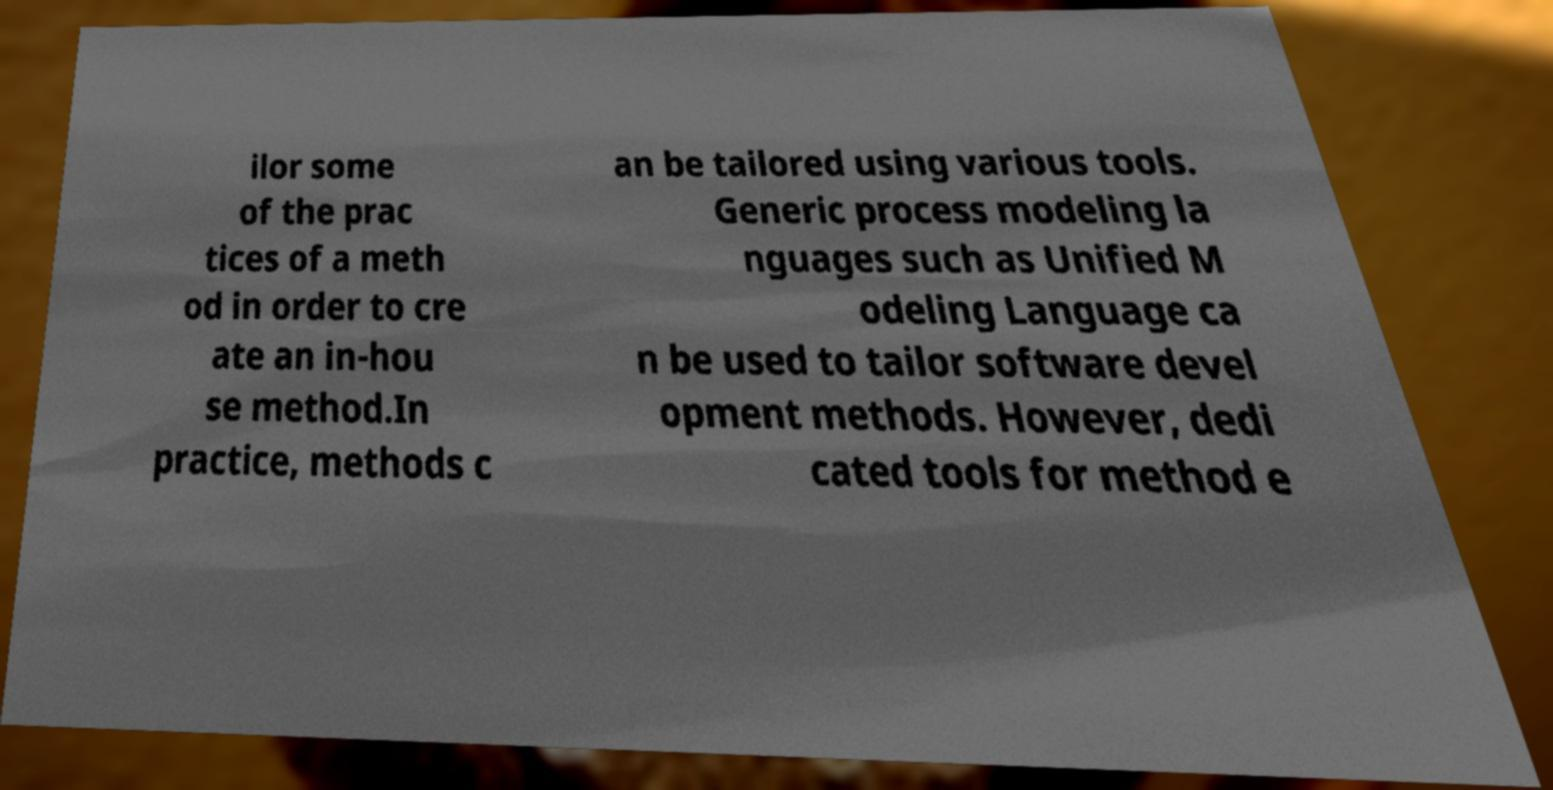Could you extract and type out the text from this image? ilor some of the prac tices of a meth od in order to cre ate an in-hou se method.In practice, methods c an be tailored using various tools. Generic process modeling la nguages such as Unified M odeling Language ca n be used to tailor software devel opment methods. However, dedi cated tools for method e 